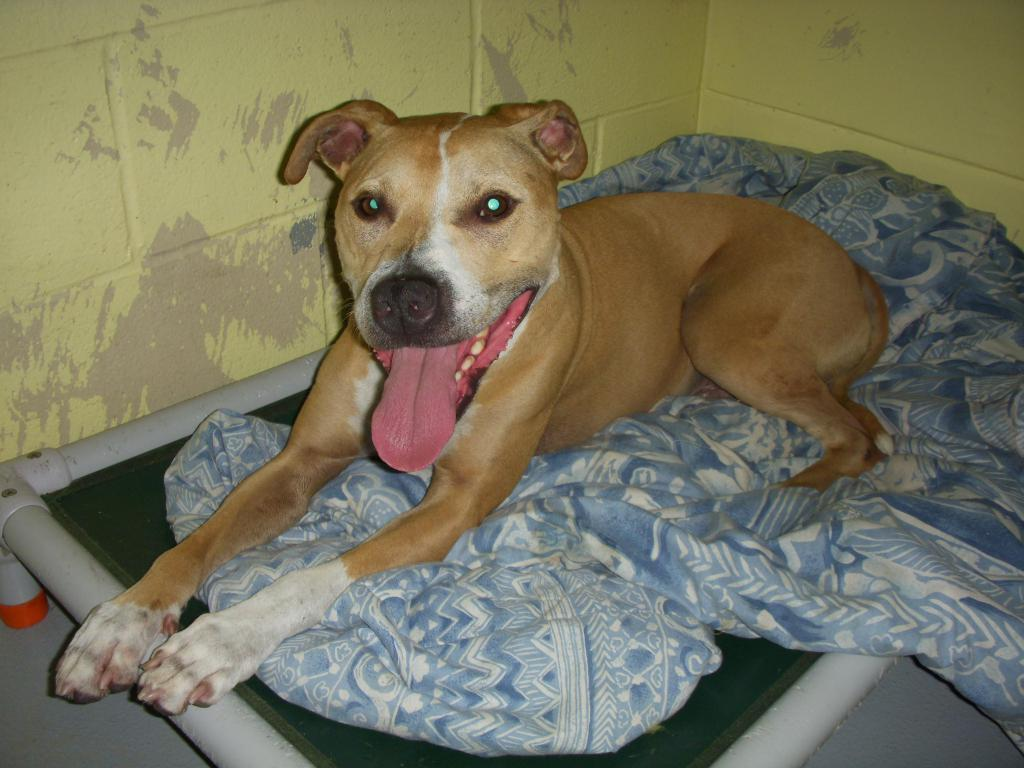What type of animal can be seen in the image? There is a dog in the image. Where is the dog located? The dog is on a blanket. What is the blanket placed on? The blanket is on a bed. What part of the room is visible in the image? The floor is visible in the image. What is the background of the image? There is a wall in the image. How many bears are visible in the image? There are no bears present in the image. What type of bird can be seen running across the floor in the image? There are no birds or running animals visible in the image. 